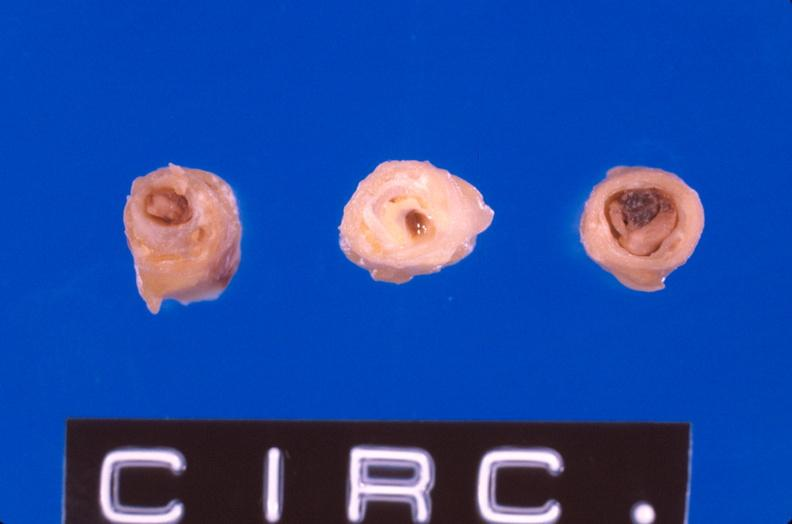s cardiovascular present?
Answer the question using a single word or phrase. Yes 